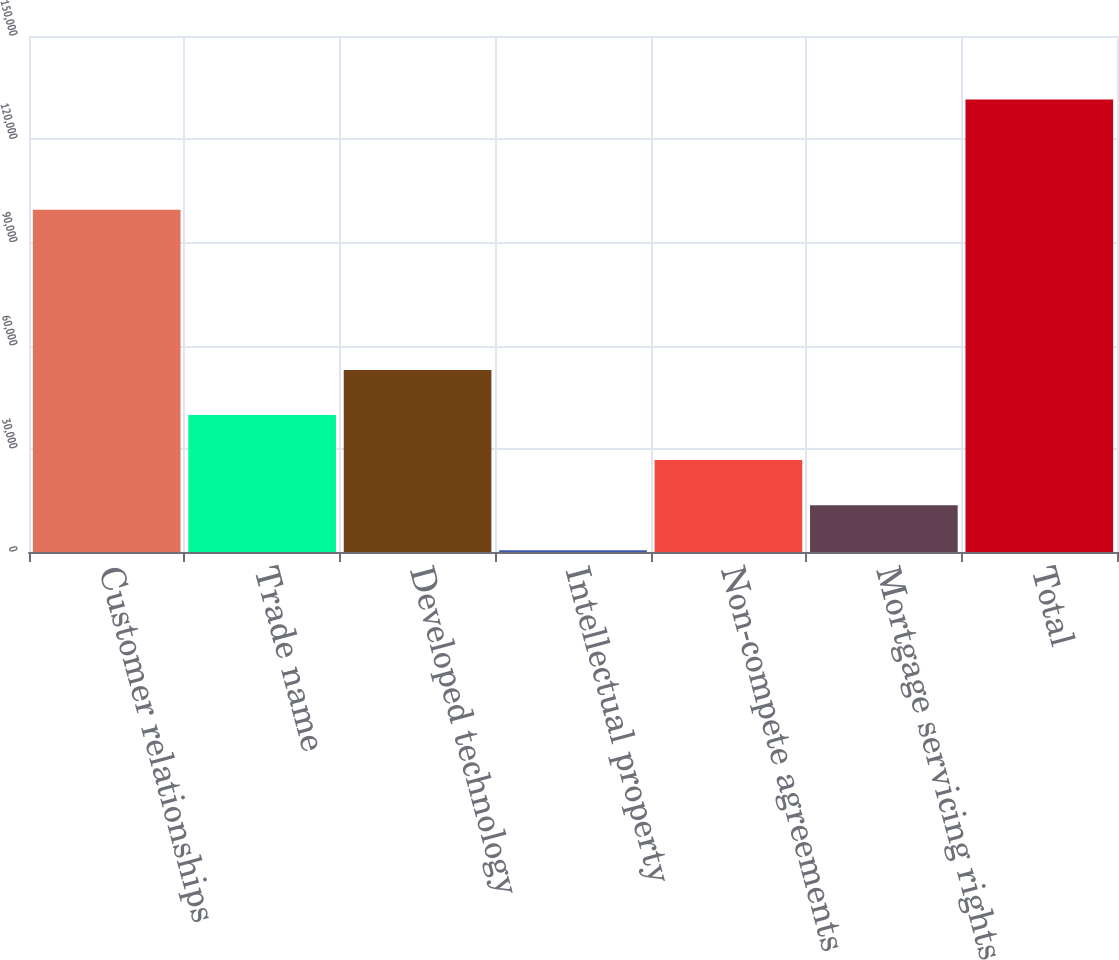Convert chart. <chart><loc_0><loc_0><loc_500><loc_500><bar_chart><fcel>Customer relationships<fcel>Trade name<fcel>Developed technology<fcel>Intellectual property<fcel>Non-compete agreements<fcel>Mortgage servicing rights<fcel>Total<nl><fcel>99470<fcel>39825<fcel>52928<fcel>516<fcel>26722<fcel>13619<fcel>131546<nl></chart> 